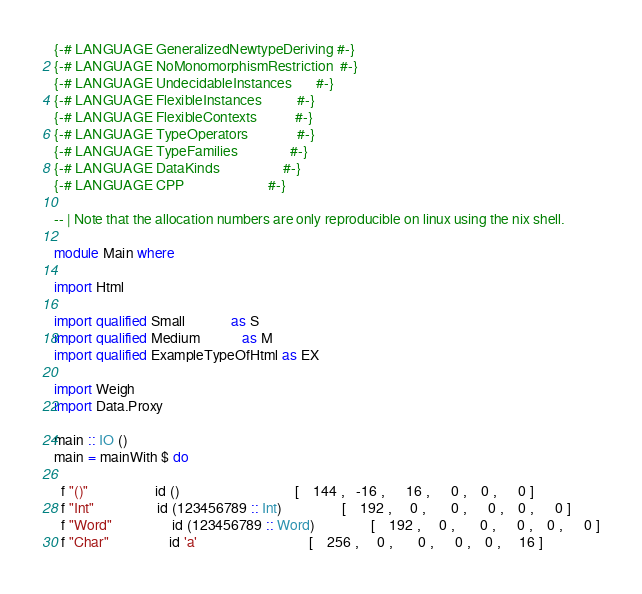<code> <loc_0><loc_0><loc_500><loc_500><_Haskell_>{-# LANGUAGE GeneralizedNewtypeDeriving #-}
{-# LANGUAGE NoMonomorphismRestriction  #-}
{-# LANGUAGE UndecidableInstances       #-}
{-# LANGUAGE FlexibleInstances          #-}
{-# LANGUAGE FlexibleContexts           #-}
{-# LANGUAGE TypeOperators              #-}
{-# LANGUAGE TypeFamilies               #-}
{-# LANGUAGE DataKinds                  #-}
{-# LANGUAGE CPP                        #-}

-- | Note that the allocation numbers are only reproducible on linux using the nix shell.

module Main where

import Html

import qualified Small             as S
import qualified Medium            as M
import qualified ExampleTypeOfHtml as EX

import Weigh
import Data.Proxy

main :: IO ()
main = mainWith $ do

  f "()"                   id ()                                 [    144 ,   -16 ,      16 ,      0 ,    0 ,      0 ]
  f "Int"                  id (123456789 :: Int)                 [    192 ,     0 ,       0 ,      0 ,    0 ,      0 ]
  f "Word"                 id (123456789 :: Word)                [    192 ,     0 ,       0 ,      0 ,    0 ,      0 ]
  f "Char"                 id 'a'                                [    256 ,     0 ,       0 ,      0 ,    0 ,     16 ]</code> 